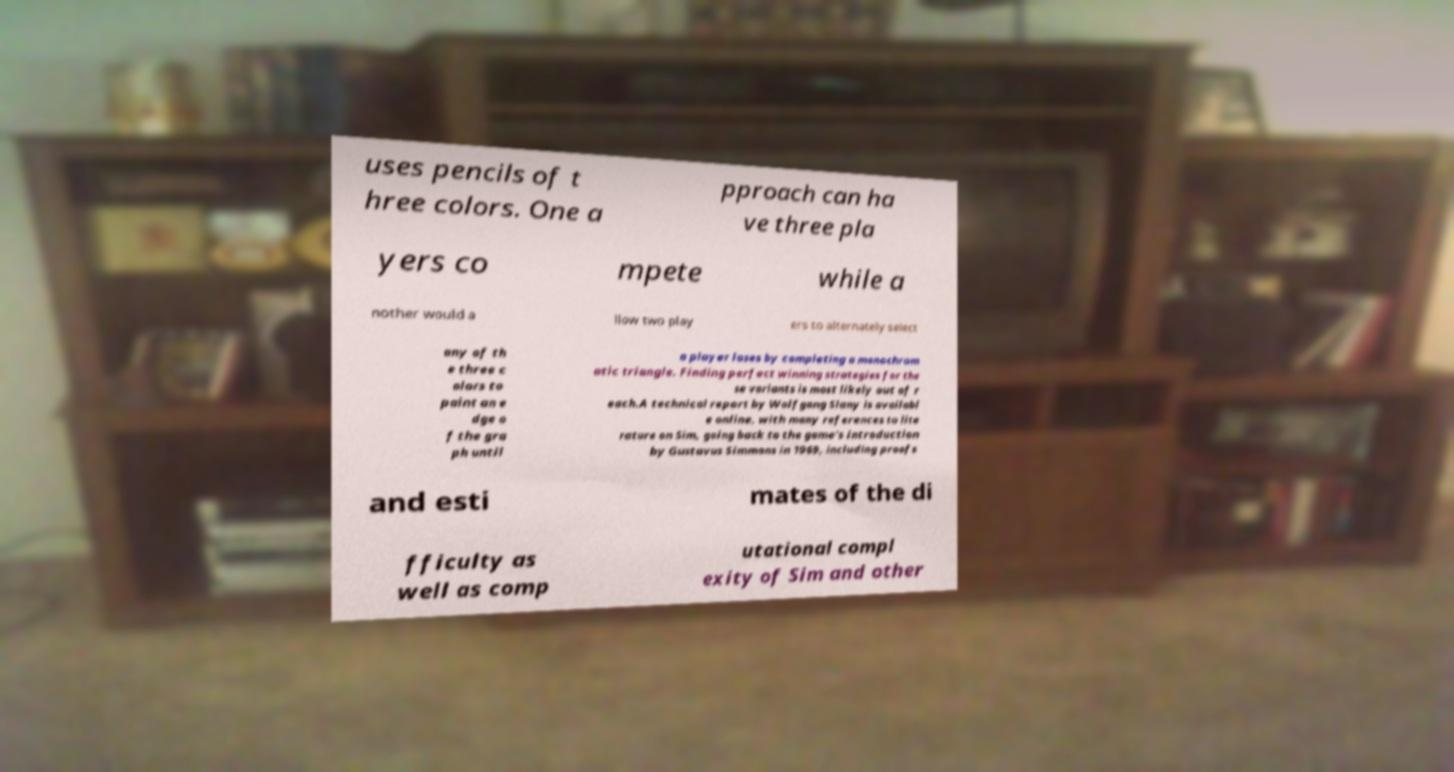For documentation purposes, I need the text within this image transcribed. Could you provide that? uses pencils of t hree colors. One a pproach can ha ve three pla yers co mpete while a nother would a llow two play ers to alternately select any of th e three c olors to paint an e dge o f the gra ph until a player loses by completing a monochrom atic triangle. Finding perfect winning strategies for the se variants is most likely out of r each.A technical report by Wolfgang Slany is availabl e online, with many references to lite rature on Sim, going back to the game's introduction by Gustavus Simmons in 1969, including proofs and esti mates of the di fficulty as well as comp utational compl exity of Sim and other 